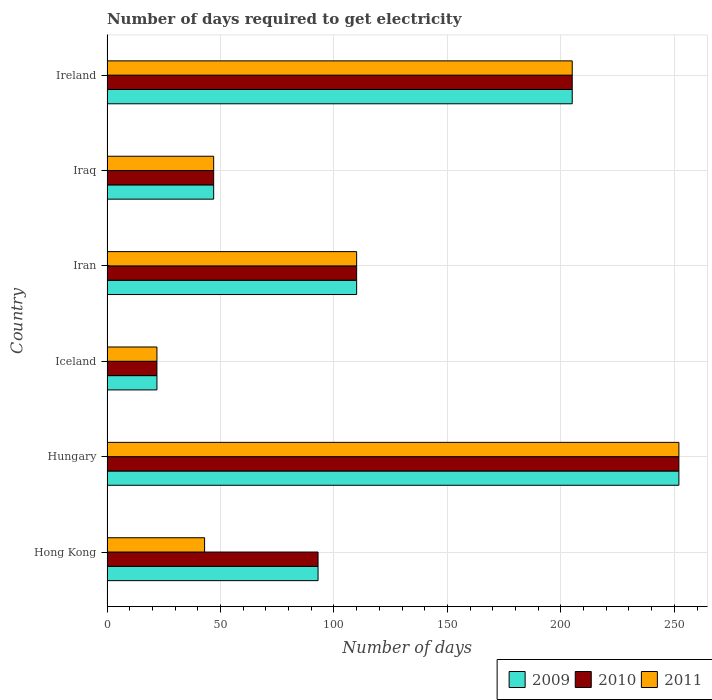How many groups of bars are there?
Ensure brevity in your answer.  6. Are the number of bars per tick equal to the number of legend labels?
Keep it short and to the point. Yes. Are the number of bars on each tick of the Y-axis equal?
Offer a terse response. Yes. How many bars are there on the 2nd tick from the bottom?
Provide a short and direct response. 3. In how many cases, is the number of bars for a given country not equal to the number of legend labels?
Your answer should be compact. 0. What is the number of days required to get electricity in in 2011 in Ireland?
Your response must be concise. 205. Across all countries, what is the maximum number of days required to get electricity in in 2010?
Ensure brevity in your answer.  252. In which country was the number of days required to get electricity in in 2010 maximum?
Keep it short and to the point. Hungary. In which country was the number of days required to get electricity in in 2011 minimum?
Keep it short and to the point. Iceland. What is the total number of days required to get electricity in in 2011 in the graph?
Offer a terse response. 679. What is the difference between the number of days required to get electricity in in 2010 in Hong Kong and the number of days required to get electricity in in 2011 in Ireland?
Give a very brief answer. -112. What is the average number of days required to get electricity in in 2009 per country?
Your response must be concise. 121.5. What is the ratio of the number of days required to get electricity in in 2011 in Iceland to that in Iraq?
Your answer should be very brief. 0.47. Is the difference between the number of days required to get electricity in in 2010 in Hungary and Iceland greater than the difference between the number of days required to get electricity in in 2009 in Hungary and Iceland?
Keep it short and to the point. No. What is the difference between the highest and the second highest number of days required to get electricity in in 2010?
Your answer should be compact. 47. What is the difference between the highest and the lowest number of days required to get electricity in in 2010?
Provide a succinct answer. 230. In how many countries, is the number of days required to get electricity in in 2011 greater than the average number of days required to get electricity in in 2011 taken over all countries?
Your answer should be very brief. 2. Is the sum of the number of days required to get electricity in in 2010 in Hungary and Iceland greater than the maximum number of days required to get electricity in in 2009 across all countries?
Keep it short and to the point. Yes. What does the 1st bar from the bottom in Hungary represents?
Provide a succinct answer. 2009. Is it the case that in every country, the sum of the number of days required to get electricity in in 2010 and number of days required to get electricity in in 2009 is greater than the number of days required to get electricity in in 2011?
Provide a short and direct response. Yes. Does the graph contain any zero values?
Make the answer very short. No. Does the graph contain grids?
Offer a terse response. Yes. Where does the legend appear in the graph?
Your answer should be very brief. Bottom right. How are the legend labels stacked?
Your answer should be very brief. Horizontal. What is the title of the graph?
Offer a terse response. Number of days required to get electricity. Does "1984" appear as one of the legend labels in the graph?
Provide a short and direct response. No. What is the label or title of the X-axis?
Give a very brief answer. Number of days. What is the Number of days of 2009 in Hong Kong?
Offer a terse response. 93. What is the Number of days in 2010 in Hong Kong?
Provide a short and direct response. 93. What is the Number of days in 2009 in Hungary?
Offer a very short reply. 252. What is the Number of days of 2010 in Hungary?
Ensure brevity in your answer.  252. What is the Number of days in 2011 in Hungary?
Keep it short and to the point. 252. What is the Number of days in 2009 in Iceland?
Your response must be concise. 22. What is the Number of days of 2010 in Iceland?
Your answer should be compact. 22. What is the Number of days of 2011 in Iceland?
Give a very brief answer. 22. What is the Number of days in 2009 in Iran?
Give a very brief answer. 110. What is the Number of days of 2010 in Iran?
Provide a succinct answer. 110. What is the Number of days in 2011 in Iran?
Keep it short and to the point. 110. What is the Number of days of 2009 in Iraq?
Give a very brief answer. 47. What is the Number of days in 2010 in Iraq?
Offer a very short reply. 47. What is the Number of days of 2011 in Iraq?
Your answer should be compact. 47. What is the Number of days in 2009 in Ireland?
Give a very brief answer. 205. What is the Number of days of 2010 in Ireland?
Your response must be concise. 205. What is the Number of days in 2011 in Ireland?
Ensure brevity in your answer.  205. Across all countries, what is the maximum Number of days of 2009?
Keep it short and to the point. 252. Across all countries, what is the maximum Number of days of 2010?
Provide a short and direct response. 252. Across all countries, what is the maximum Number of days of 2011?
Your answer should be compact. 252. Across all countries, what is the minimum Number of days of 2010?
Your response must be concise. 22. Across all countries, what is the minimum Number of days of 2011?
Offer a very short reply. 22. What is the total Number of days of 2009 in the graph?
Your answer should be very brief. 729. What is the total Number of days in 2010 in the graph?
Make the answer very short. 729. What is the total Number of days of 2011 in the graph?
Provide a short and direct response. 679. What is the difference between the Number of days of 2009 in Hong Kong and that in Hungary?
Offer a very short reply. -159. What is the difference between the Number of days of 2010 in Hong Kong and that in Hungary?
Keep it short and to the point. -159. What is the difference between the Number of days in 2011 in Hong Kong and that in Hungary?
Keep it short and to the point. -209. What is the difference between the Number of days in 2011 in Hong Kong and that in Iran?
Provide a short and direct response. -67. What is the difference between the Number of days in 2009 in Hong Kong and that in Ireland?
Provide a succinct answer. -112. What is the difference between the Number of days of 2010 in Hong Kong and that in Ireland?
Give a very brief answer. -112. What is the difference between the Number of days in 2011 in Hong Kong and that in Ireland?
Your response must be concise. -162. What is the difference between the Number of days of 2009 in Hungary and that in Iceland?
Your response must be concise. 230. What is the difference between the Number of days of 2010 in Hungary and that in Iceland?
Offer a terse response. 230. What is the difference between the Number of days in 2011 in Hungary and that in Iceland?
Offer a terse response. 230. What is the difference between the Number of days of 2009 in Hungary and that in Iran?
Keep it short and to the point. 142. What is the difference between the Number of days of 2010 in Hungary and that in Iran?
Make the answer very short. 142. What is the difference between the Number of days of 2011 in Hungary and that in Iran?
Offer a very short reply. 142. What is the difference between the Number of days of 2009 in Hungary and that in Iraq?
Your answer should be very brief. 205. What is the difference between the Number of days of 2010 in Hungary and that in Iraq?
Your response must be concise. 205. What is the difference between the Number of days of 2011 in Hungary and that in Iraq?
Your answer should be very brief. 205. What is the difference between the Number of days of 2010 in Hungary and that in Ireland?
Provide a succinct answer. 47. What is the difference between the Number of days of 2009 in Iceland and that in Iran?
Make the answer very short. -88. What is the difference between the Number of days of 2010 in Iceland and that in Iran?
Give a very brief answer. -88. What is the difference between the Number of days of 2011 in Iceland and that in Iran?
Provide a short and direct response. -88. What is the difference between the Number of days of 2009 in Iceland and that in Iraq?
Provide a short and direct response. -25. What is the difference between the Number of days of 2010 in Iceland and that in Iraq?
Your answer should be compact. -25. What is the difference between the Number of days in 2011 in Iceland and that in Iraq?
Your response must be concise. -25. What is the difference between the Number of days in 2009 in Iceland and that in Ireland?
Provide a succinct answer. -183. What is the difference between the Number of days in 2010 in Iceland and that in Ireland?
Make the answer very short. -183. What is the difference between the Number of days of 2011 in Iceland and that in Ireland?
Make the answer very short. -183. What is the difference between the Number of days in 2011 in Iran and that in Iraq?
Make the answer very short. 63. What is the difference between the Number of days of 2009 in Iran and that in Ireland?
Give a very brief answer. -95. What is the difference between the Number of days of 2010 in Iran and that in Ireland?
Your answer should be very brief. -95. What is the difference between the Number of days in 2011 in Iran and that in Ireland?
Provide a short and direct response. -95. What is the difference between the Number of days of 2009 in Iraq and that in Ireland?
Offer a very short reply. -158. What is the difference between the Number of days in 2010 in Iraq and that in Ireland?
Your answer should be very brief. -158. What is the difference between the Number of days in 2011 in Iraq and that in Ireland?
Keep it short and to the point. -158. What is the difference between the Number of days in 2009 in Hong Kong and the Number of days in 2010 in Hungary?
Offer a terse response. -159. What is the difference between the Number of days in 2009 in Hong Kong and the Number of days in 2011 in Hungary?
Your answer should be compact. -159. What is the difference between the Number of days of 2010 in Hong Kong and the Number of days of 2011 in Hungary?
Offer a terse response. -159. What is the difference between the Number of days of 2009 in Hong Kong and the Number of days of 2010 in Iceland?
Offer a very short reply. 71. What is the difference between the Number of days in 2010 in Hong Kong and the Number of days in 2011 in Iran?
Make the answer very short. -17. What is the difference between the Number of days in 2009 in Hong Kong and the Number of days in 2010 in Ireland?
Your answer should be compact. -112. What is the difference between the Number of days of 2009 in Hong Kong and the Number of days of 2011 in Ireland?
Give a very brief answer. -112. What is the difference between the Number of days in 2010 in Hong Kong and the Number of days in 2011 in Ireland?
Offer a very short reply. -112. What is the difference between the Number of days of 2009 in Hungary and the Number of days of 2010 in Iceland?
Provide a short and direct response. 230. What is the difference between the Number of days in 2009 in Hungary and the Number of days in 2011 in Iceland?
Your response must be concise. 230. What is the difference between the Number of days of 2010 in Hungary and the Number of days of 2011 in Iceland?
Your answer should be compact. 230. What is the difference between the Number of days in 2009 in Hungary and the Number of days in 2010 in Iran?
Keep it short and to the point. 142. What is the difference between the Number of days in 2009 in Hungary and the Number of days in 2011 in Iran?
Provide a succinct answer. 142. What is the difference between the Number of days of 2010 in Hungary and the Number of days of 2011 in Iran?
Your answer should be very brief. 142. What is the difference between the Number of days of 2009 in Hungary and the Number of days of 2010 in Iraq?
Keep it short and to the point. 205. What is the difference between the Number of days in 2009 in Hungary and the Number of days in 2011 in Iraq?
Offer a terse response. 205. What is the difference between the Number of days of 2010 in Hungary and the Number of days of 2011 in Iraq?
Provide a short and direct response. 205. What is the difference between the Number of days in 2009 in Hungary and the Number of days in 2011 in Ireland?
Give a very brief answer. 47. What is the difference between the Number of days of 2009 in Iceland and the Number of days of 2010 in Iran?
Ensure brevity in your answer.  -88. What is the difference between the Number of days in 2009 in Iceland and the Number of days in 2011 in Iran?
Your response must be concise. -88. What is the difference between the Number of days of 2010 in Iceland and the Number of days of 2011 in Iran?
Give a very brief answer. -88. What is the difference between the Number of days in 2009 in Iceland and the Number of days in 2010 in Iraq?
Provide a succinct answer. -25. What is the difference between the Number of days of 2009 in Iceland and the Number of days of 2011 in Iraq?
Give a very brief answer. -25. What is the difference between the Number of days of 2010 in Iceland and the Number of days of 2011 in Iraq?
Your answer should be compact. -25. What is the difference between the Number of days in 2009 in Iceland and the Number of days in 2010 in Ireland?
Offer a very short reply. -183. What is the difference between the Number of days in 2009 in Iceland and the Number of days in 2011 in Ireland?
Provide a short and direct response. -183. What is the difference between the Number of days in 2010 in Iceland and the Number of days in 2011 in Ireland?
Your answer should be very brief. -183. What is the difference between the Number of days of 2009 in Iran and the Number of days of 2010 in Iraq?
Your response must be concise. 63. What is the difference between the Number of days of 2009 in Iran and the Number of days of 2011 in Iraq?
Provide a short and direct response. 63. What is the difference between the Number of days of 2009 in Iran and the Number of days of 2010 in Ireland?
Your response must be concise. -95. What is the difference between the Number of days in 2009 in Iran and the Number of days in 2011 in Ireland?
Give a very brief answer. -95. What is the difference between the Number of days in 2010 in Iran and the Number of days in 2011 in Ireland?
Your answer should be very brief. -95. What is the difference between the Number of days of 2009 in Iraq and the Number of days of 2010 in Ireland?
Your answer should be compact. -158. What is the difference between the Number of days in 2009 in Iraq and the Number of days in 2011 in Ireland?
Give a very brief answer. -158. What is the difference between the Number of days in 2010 in Iraq and the Number of days in 2011 in Ireland?
Provide a succinct answer. -158. What is the average Number of days in 2009 per country?
Offer a terse response. 121.5. What is the average Number of days in 2010 per country?
Make the answer very short. 121.5. What is the average Number of days in 2011 per country?
Ensure brevity in your answer.  113.17. What is the difference between the Number of days in 2009 and Number of days in 2010 in Hong Kong?
Provide a short and direct response. 0. What is the difference between the Number of days in 2009 and Number of days in 2011 in Hong Kong?
Give a very brief answer. 50. What is the difference between the Number of days in 2009 and Number of days in 2010 in Hungary?
Ensure brevity in your answer.  0. What is the difference between the Number of days of 2009 and Number of days of 2011 in Iceland?
Your answer should be very brief. 0. What is the difference between the Number of days in 2009 and Number of days in 2010 in Iran?
Provide a short and direct response. 0. What is the difference between the Number of days of 2009 and Number of days of 2011 in Iran?
Your response must be concise. 0. What is the difference between the Number of days in 2009 and Number of days in 2010 in Ireland?
Ensure brevity in your answer.  0. What is the difference between the Number of days in 2009 and Number of days in 2011 in Ireland?
Give a very brief answer. 0. What is the difference between the Number of days of 2010 and Number of days of 2011 in Ireland?
Your answer should be compact. 0. What is the ratio of the Number of days in 2009 in Hong Kong to that in Hungary?
Give a very brief answer. 0.37. What is the ratio of the Number of days in 2010 in Hong Kong to that in Hungary?
Your response must be concise. 0.37. What is the ratio of the Number of days in 2011 in Hong Kong to that in Hungary?
Offer a terse response. 0.17. What is the ratio of the Number of days in 2009 in Hong Kong to that in Iceland?
Your answer should be very brief. 4.23. What is the ratio of the Number of days of 2010 in Hong Kong to that in Iceland?
Your response must be concise. 4.23. What is the ratio of the Number of days in 2011 in Hong Kong to that in Iceland?
Provide a succinct answer. 1.95. What is the ratio of the Number of days in 2009 in Hong Kong to that in Iran?
Your answer should be very brief. 0.85. What is the ratio of the Number of days of 2010 in Hong Kong to that in Iran?
Offer a very short reply. 0.85. What is the ratio of the Number of days of 2011 in Hong Kong to that in Iran?
Offer a very short reply. 0.39. What is the ratio of the Number of days in 2009 in Hong Kong to that in Iraq?
Give a very brief answer. 1.98. What is the ratio of the Number of days of 2010 in Hong Kong to that in Iraq?
Your answer should be compact. 1.98. What is the ratio of the Number of days of 2011 in Hong Kong to that in Iraq?
Offer a very short reply. 0.91. What is the ratio of the Number of days of 2009 in Hong Kong to that in Ireland?
Keep it short and to the point. 0.45. What is the ratio of the Number of days of 2010 in Hong Kong to that in Ireland?
Give a very brief answer. 0.45. What is the ratio of the Number of days in 2011 in Hong Kong to that in Ireland?
Give a very brief answer. 0.21. What is the ratio of the Number of days of 2009 in Hungary to that in Iceland?
Provide a short and direct response. 11.45. What is the ratio of the Number of days in 2010 in Hungary to that in Iceland?
Your answer should be very brief. 11.45. What is the ratio of the Number of days in 2011 in Hungary to that in Iceland?
Ensure brevity in your answer.  11.45. What is the ratio of the Number of days of 2009 in Hungary to that in Iran?
Offer a terse response. 2.29. What is the ratio of the Number of days of 2010 in Hungary to that in Iran?
Provide a short and direct response. 2.29. What is the ratio of the Number of days of 2011 in Hungary to that in Iran?
Ensure brevity in your answer.  2.29. What is the ratio of the Number of days in 2009 in Hungary to that in Iraq?
Keep it short and to the point. 5.36. What is the ratio of the Number of days in 2010 in Hungary to that in Iraq?
Your response must be concise. 5.36. What is the ratio of the Number of days of 2011 in Hungary to that in Iraq?
Your answer should be compact. 5.36. What is the ratio of the Number of days of 2009 in Hungary to that in Ireland?
Provide a short and direct response. 1.23. What is the ratio of the Number of days in 2010 in Hungary to that in Ireland?
Give a very brief answer. 1.23. What is the ratio of the Number of days in 2011 in Hungary to that in Ireland?
Your answer should be compact. 1.23. What is the ratio of the Number of days in 2009 in Iceland to that in Iran?
Your answer should be compact. 0.2. What is the ratio of the Number of days in 2010 in Iceland to that in Iran?
Your answer should be compact. 0.2. What is the ratio of the Number of days of 2011 in Iceland to that in Iran?
Offer a terse response. 0.2. What is the ratio of the Number of days of 2009 in Iceland to that in Iraq?
Provide a succinct answer. 0.47. What is the ratio of the Number of days of 2010 in Iceland to that in Iraq?
Provide a short and direct response. 0.47. What is the ratio of the Number of days of 2011 in Iceland to that in Iraq?
Offer a very short reply. 0.47. What is the ratio of the Number of days of 2009 in Iceland to that in Ireland?
Offer a very short reply. 0.11. What is the ratio of the Number of days in 2010 in Iceland to that in Ireland?
Keep it short and to the point. 0.11. What is the ratio of the Number of days in 2011 in Iceland to that in Ireland?
Offer a terse response. 0.11. What is the ratio of the Number of days in 2009 in Iran to that in Iraq?
Provide a succinct answer. 2.34. What is the ratio of the Number of days in 2010 in Iran to that in Iraq?
Your answer should be very brief. 2.34. What is the ratio of the Number of days in 2011 in Iran to that in Iraq?
Give a very brief answer. 2.34. What is the ratio of the Number of days of 2009 in Iran to that in Ireland?
Keep it short and to the point. 0.54. What is the ratio of the Number of days in 2010 in Iran to that in Ireland?
Offer a terse response. 0.54. What is the ratio of the Number of days of 2011 in Iran to that in Ireland?
Give a very brief answer. 0.54. What is the ratio of the Number of days in 2009 in Iraq to that in Ireland?
Offer a very short reply. 0.23. What is the ratio of the Number of days of 2010 in Iraq to that in Ireland?
Your response must be concise. 0.23. What is the ratio of the Number of days of 2011 in Iraq to that in Ireland?
Provide a succinct answer. 0.23. What is the difference between the highest and the second highest Number of days of 2009?
Offer a terse response. 47. What is the difference between the highest and the second highest Number of days in 2010?
Give a very brief answer. 47. What is the difference between the highest and the lowest Number of days in 2009?
Your answer should be compact. 230. What is the difference between the highest and the lowest Number of days of 2010?
Your response must be concise. 230. What is the difference between the highest and the lowest Number of days in 2011?
Ensure brevity in your answer.  230. 